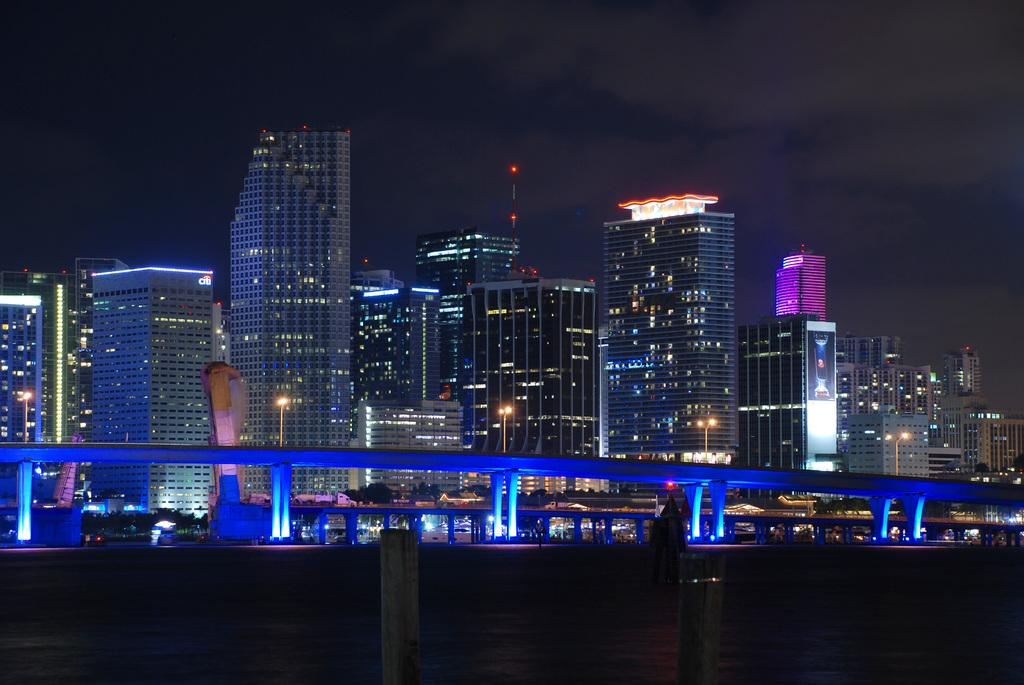What structures can be seen in the image? There are poles, buildings, bridges, and a poster in the image. What type of illumination is present in the image? There are lights in the image. What type of vegetation is visible in the image? There are trees in the image. What objects can be seen in the image? There are some objects in the image. What can be seen in the background of the image? The sky is visible in the background of the image. How does the grip of the unit affect the lip in the image? There is no mention of a grip, unit, or lip in the image, so this question cannot be answered. 